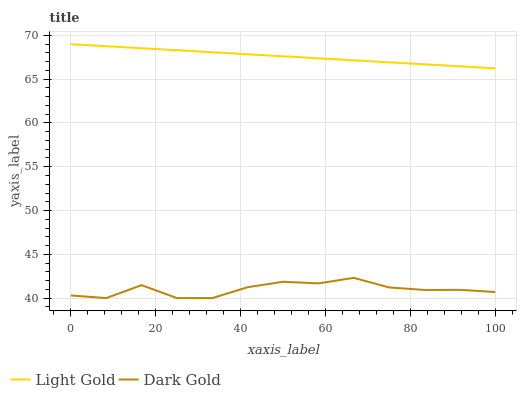Does Dark Gold have the minimum area under the curve?
Answer yes or no. Yes. Does Light Gold have the maximum area under the curve?
Answer yes or no. Yes. Does Dark Gold have the maximum area under the curve?
Answer yes or no. No. Is Light Gold the smoothest?
Answer yes or no. Yes. Is Dark Gold the roughest?
Answer yes or no. Yes. Is Dark Gold the smoothest?
Answer yes or no. No. Does Dark Gold have the lowest value?
Answer yes or no. Yes. Does Light Gold have the highest value?
Answer yes or no. Yes. Does Dark Gold have the highest value?
Answer yes or no. No. Is Dark Gold less than Light Gold?
Answer yes or no. Yes. Is Light Gold greater than Dark Gold?
Answer yes or no. Yes. Does Dark Gold intersect Light Gold?
Answer yes or no. No. 